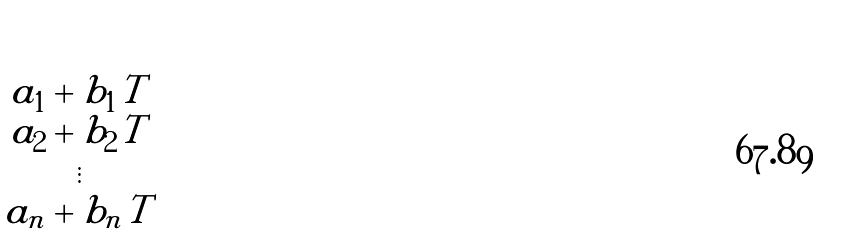Convert formula to latex. <formula><loc_0><loc_0><loc_500><loc_500>\begin{pmatrix} a _ { 1 } + b _ { 1 } T \\ a _ { 2 } + b _ { 2 } T \\ \vdots \\ a _ { n } + b _ { n } T \end{pmatrix}</formula> 